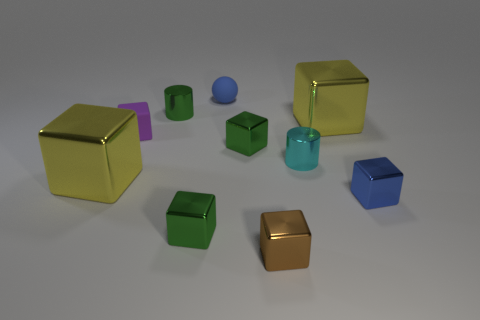Subtract all tiny matte cubes. How many cubes are left? 6 Subtract all yellow blocks. How many blocks are left? 5 Subtract 2 blocks. How many blocks are left? 5 Subtract all blue blocks. Subtract all green spheres. How many blocks are left? 6 Subtract all cylinders. How many objects are left? 8 Subtract 0 green spheres. How many objects are left? 10 Subtract all tiny brown rubber cylinders. Subtract all purple things. How many objects are left? 9 Add 5 blue rubber balls. How many blue rubber balls are left? 6 Add 3 big objects. How many big objects exist? 5 